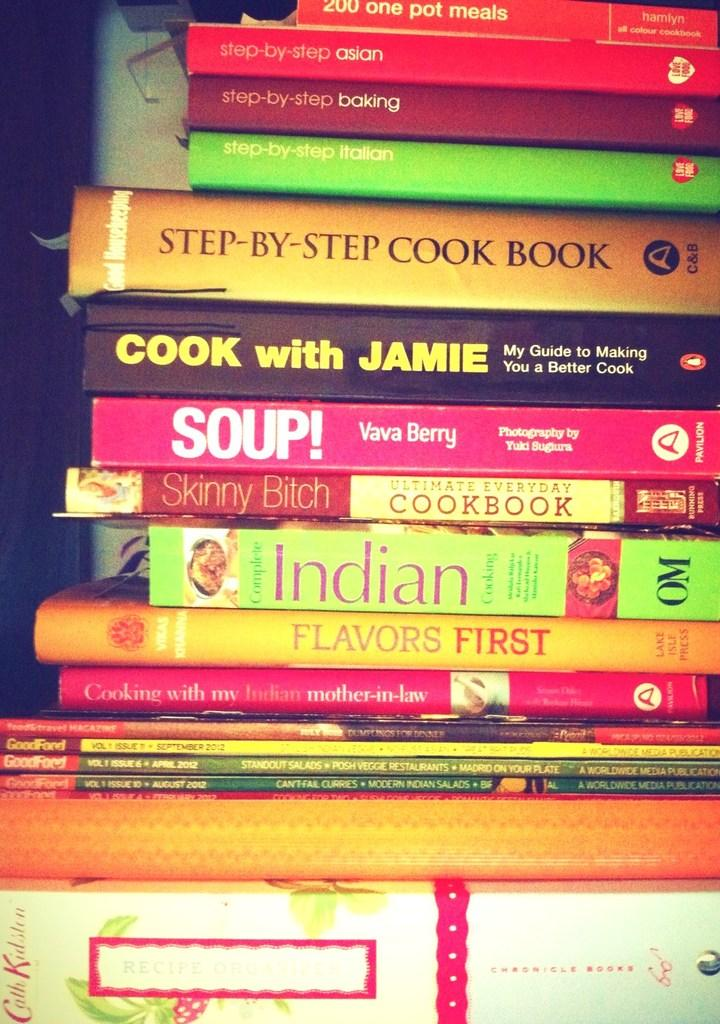<image>
Create a compact narrative representing the image presented. Book titled Step-By-Step Cook Book in between a stack of other books. 